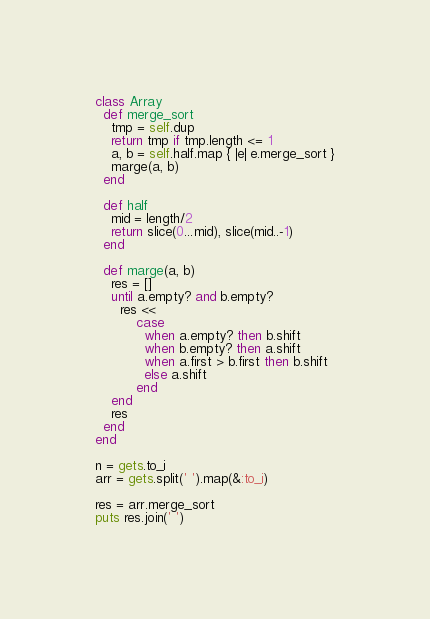Convert code to text. <code><loc_0><loc_0><loc_500><loc_500><_Ruby_>class Array
  def merge_sort
    tmp = self.dup
    return tmp if tmp.length <= 1
    a, b = self.half.map { |e| e.merge_sort }
    marge(a, b)
  end

  def half
    mid = length/2
    return slice(0...mid), slice(mid..-1)
  end

  def marge(a, b)
    res = []
    until a.empty? and b.empty?
      res <<
          case
            when a.empty? then b.shift
            when b.empty? then a.shift
            when a.first > b.first then b.shift
            else a.shift
          end
    end
    res
  end
end

n = gets.to_i
arr = gets.split(' ').map(&:to_i)

res = arr.merge_sort
puts res.join(' ')</code> 